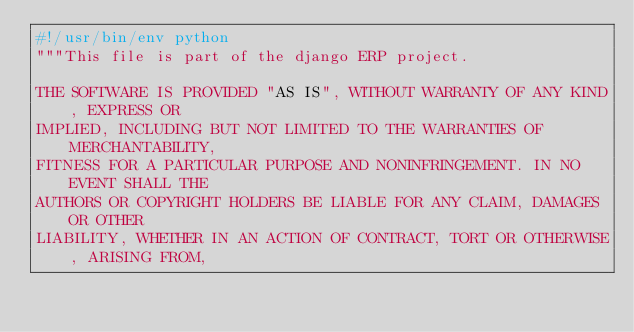Convert code to text. <code><loc_0><loc_0><loc_500><loc_500><_Python_>#!/usr/bin/env python
"""This file is part of the django ERP project.

THE SOFTWARE IS PROVIDED "AS IS", WITHOUT WARRANTY OF ANY KIND, EXPRESS OR
IMPLIED, INCLUDING BUT NOT LIMITED TO THE WARRANTIES OF MERCHANTABILITY,
FITNESS FOR A PARTICULAR PURPOSE AND NONINFRINGEMENT. IN NO EVENT SHALL THE
AUTHORS OR COPYRIGHT HOLDERS BE LIABLE FOR ANY CLAIM, DAMAGES OR OTHER
LIABILITY, WHETHER IN AN ACTION OF CONTRACT, TORT OR OTHERWISE, ARISING FROM,</code> 